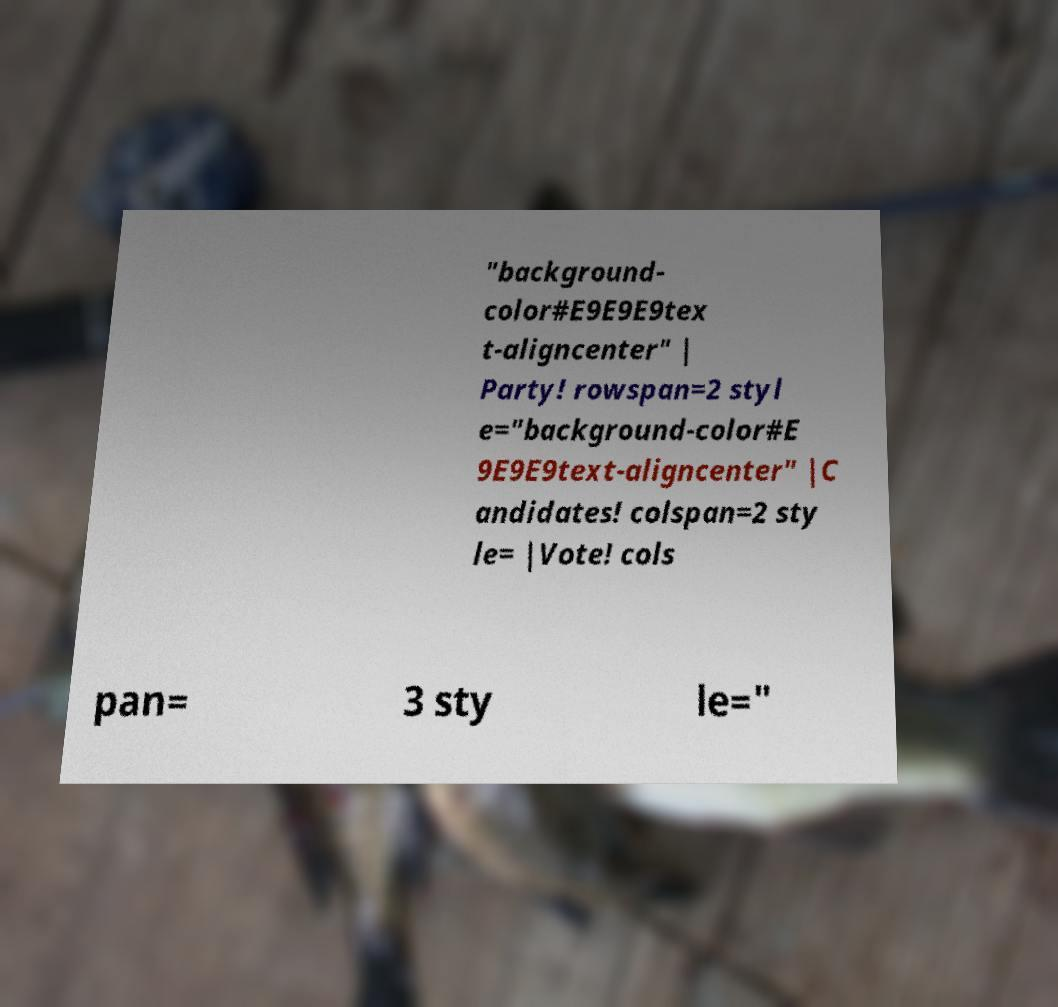Please read and relay the text visible in this image. What does it say? "background- color#E9E9E9tex t-aligncenter" | Party! rowspan=2 styl e="background-color#E 9E9E9text-aligncenter" |C andidates! colspan=2 sty le= |Vote! cols pan= 3 sty le=" 